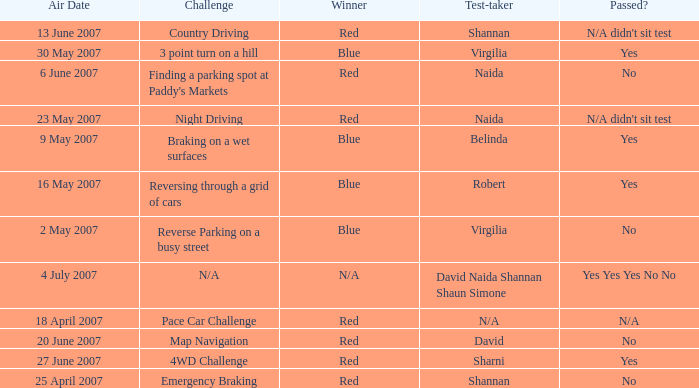On which air date was Robert the test-taker? 16 May 2007. 